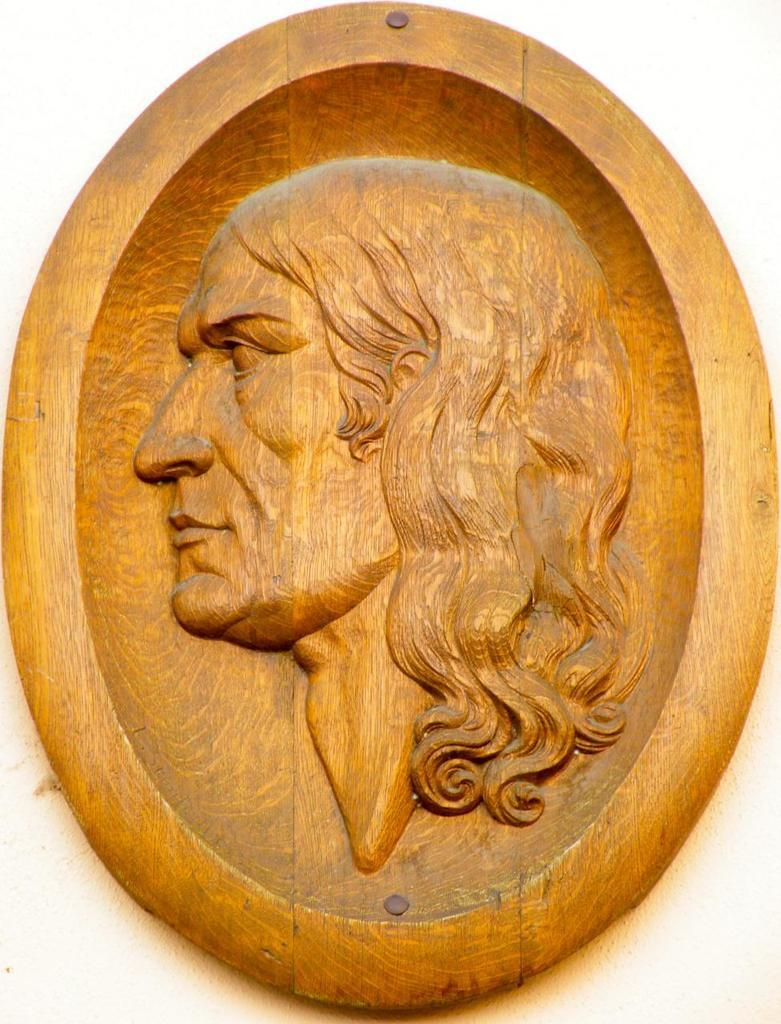What type of object is featured in the image? There is a wooden frame in the image. What is depicted on the wooden frame? The wooden frame has a carving of a person. What type of bun is being served at the team's position in the image? There is no bun or team present in the image; it only features a wooden frame with a carving of a person. 